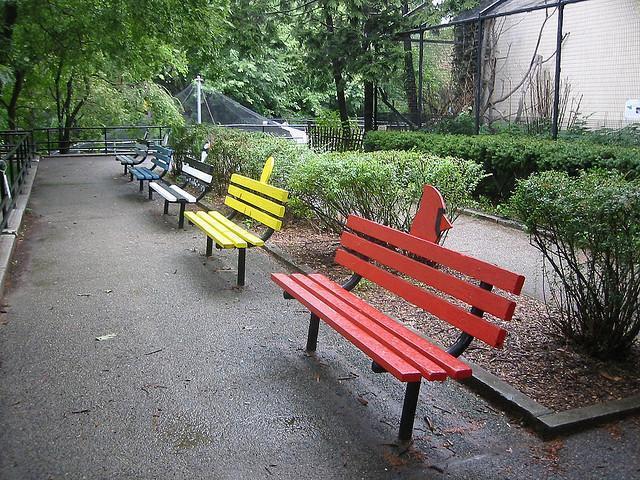How many benches are in the picture?
Give a very brief answer. 3. How many elephants are there?
Give a very brief answer. 0. 